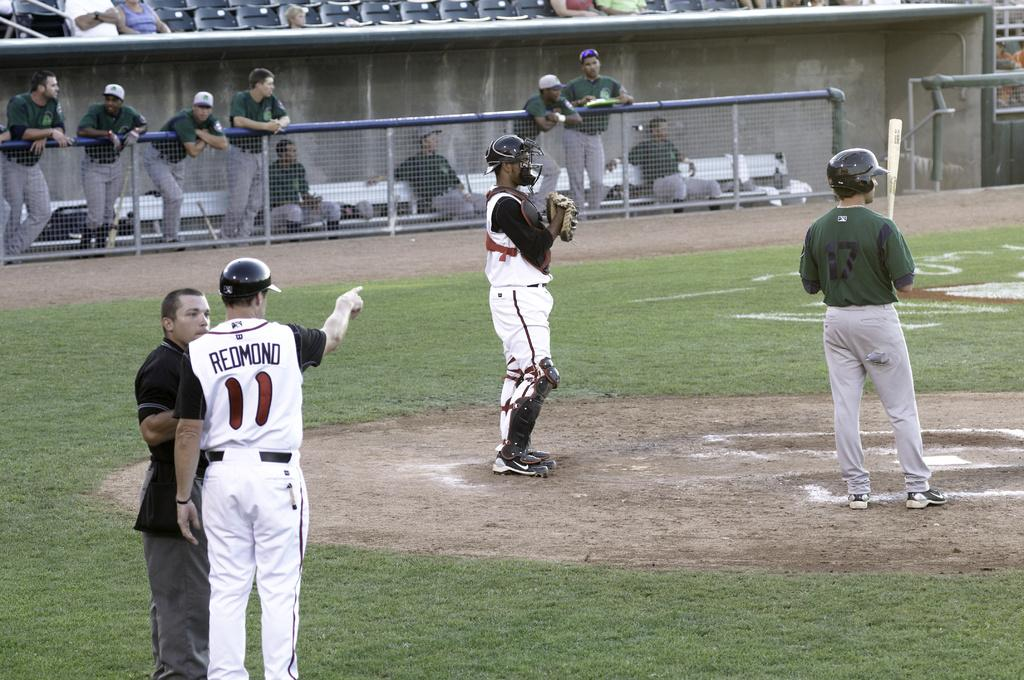<image>
Provide a brief description of the given image. A baseball player pointing and wearing a white shirt with the name Redmond on the back 